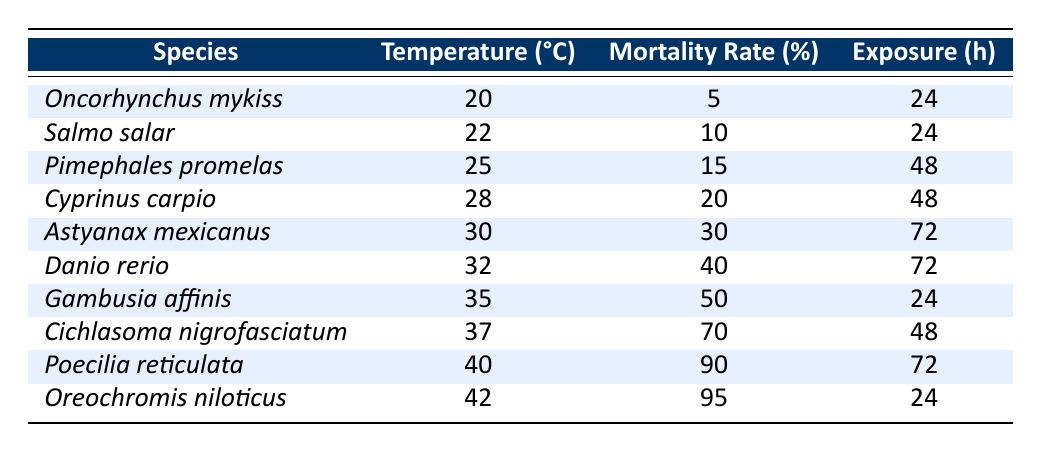What is the mortality rate of *Danio rerio* at 32 °C? From the table, the entry for *Danio rerio* shows a mortality rate of 40% at a temperature of 32 °C.
Answer: 40% Which species has the highest mortality rate and what is that rate? The table indicates that *Oreochromis niloticus* has the highest mortality rate at 95%.
Answer: *Oreochromis niloticus*, 95% How many species have a mortality rate greater than 50%? The table lists *Cichlasoma nigrofasciatum*, *Poecilia reticulata*, and *Oreochromis niloticus* as having mortality rates greater than 50%. This gives a total of 3 species.
Answer: 3 What is the average mortality rate for species exposed to temperatures of 30 °C and higher? The species with temperatures of 30 °C and above are *Astyanax mexicanus* (30%), *Danio rerio* (40%), *Gambusia affinis* (50%), *Cichlasoma nigrofasciatum* (70%), *Poecilia reticulata* (90%), and *Oreochromis niloticus* (95%). Summing their rates gives (30 + 40 + 50 + 70 + 90 + 95) = 375. There are 6 species, so the average is 375 / 6 ≈ 62.5%.
Answer: 62.5% Is there any species with a mortality rate of exactly 15%? The table does not list any species with a mortality rate of exactly 15%.
Answer: No What is the total mortality rate of species at 24 °C? The species at 24 °C are *Oncorhynchus mykiss* (5%), *Salmo salar* (10%), and *Gambusia affinis* (50%). Adding these rates gives 5 + 10 + 50 = 65%.
Answer: 65% Is the mortality rate of *Cyprinus carpio* less than the mortality rate of *Pimephales promelas*? The table shows *Cyprinus carpio* has a mortality rate of 20% while *Pimephales promelas* has a rate of 15%, making *Cyprinus carpio* higher.
Answer: No What is the difference in mortality rate between *Poecilia reticulata* and *Salmo salar*? The mortality rate of *Poecilia reticulata* is 90% and that of *Salmo salar* is 10%. The difference is 90 - 10 = 80%.
Answer: 80% Which species has a lower mortality rate, *Astyanax mexicanus* or *Cichlasoma nigrofasciatum*? *Astyanax mexicanus* has a mortality rate of 30% while *Cichlasoma nigrofasciatum* has a rate of 70%. Therefore, *Astyanax mexicanus* has the lower rate.
Answer: *Astyanax mexicanus* How many hours were the fish exposed when the mortality rate was at 90%? The table indicates that *Poecilia reticulata*, exposed for 72 hours, had a mortality rate of 90%.
Answer: 72 hours 